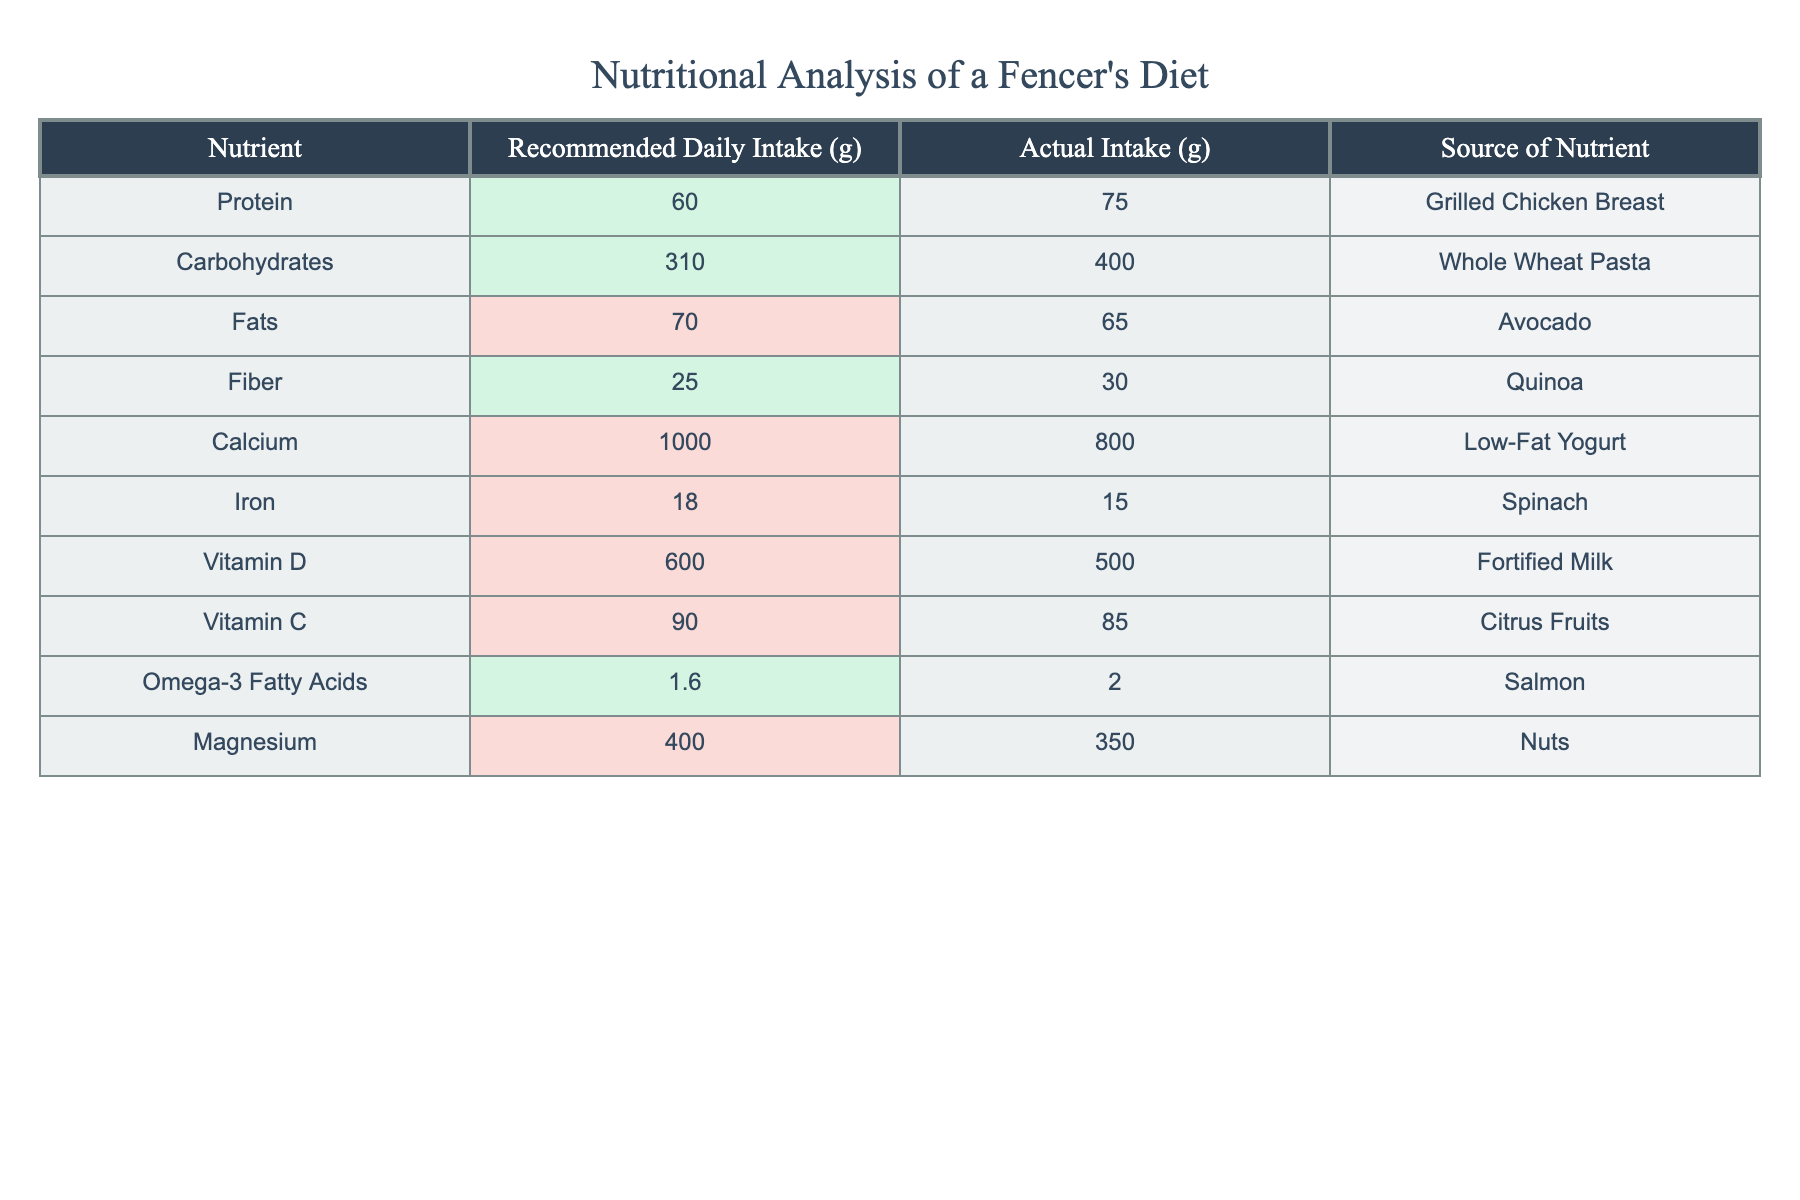What is the actual intake of protein? The table directly lists the actual intake of protein as 75 grams under the 'Actual Intake (g)' column for protein.
Answer: 75 Is the actual intake of fats below the recommended daily intake? The recommended daily intake of fats is 70 grams, and the actual intake is 65 grams. Since 65 is less than 70, it is below the recommended amount.
Answer: Yes What is the difference between the actual intake and recommended intake of calcium? The recommended intake of calcium is 1000 grams, and the actual intake is 800 grams. The difference is calculated by subtracting the actual from the recommended: 1000 - 800 = 200 grams.
Answer: 200 How much more carbohydrates are consumed than the recommended daily intake? The recommended intake of carbohydrates is 310 grams, and the actual intake is 400 grams. To find the excess, we subtract: 400 - 310 = 90 grams more carbohydrates are consumed than recommended.
Answer: 90 Are there any nutrients where the actual intake exceeds the recommended intake? By checking the table, we see that actual intakes of protein, carbohydrates, fiber, and omega-3 fatty acids exceed their recommended amounts, confirming that there are indeed nutrients with higher actual intake.
Answer: Yes What is the average actual intake of the nutrients listed? To calculate the average, first sum all actual intakes: 75 + 400 + 65 + 30 + 800 + 15 + 500 + 85 + 2 + 350 = 1952 grams. Then divide by the number of nutrients (10) to find the average: 1952 / 10 = 195.2 grams.
Answer: 195.2 Which nutrient has the highest actual intake among them? From the table, the nutrient with the highest actual intake is carbohydrates, which is 400 grams.
Answer: Carbohydrates Is the actual intake of Vitamin D adequate based on the recommendation? The recommended intake for Vitamin D is 600 grams, while the actual intake is 500 grams, which is below the recommended amount indicating it is not adequate.
Answer: No What nutrient has the lowest actual intake value? The actual intake of iron is 15 grams, which is the lowest value among the listed nutrients, compared to the others like protein and carbohydrates which have higher values.
Answer: Iron 